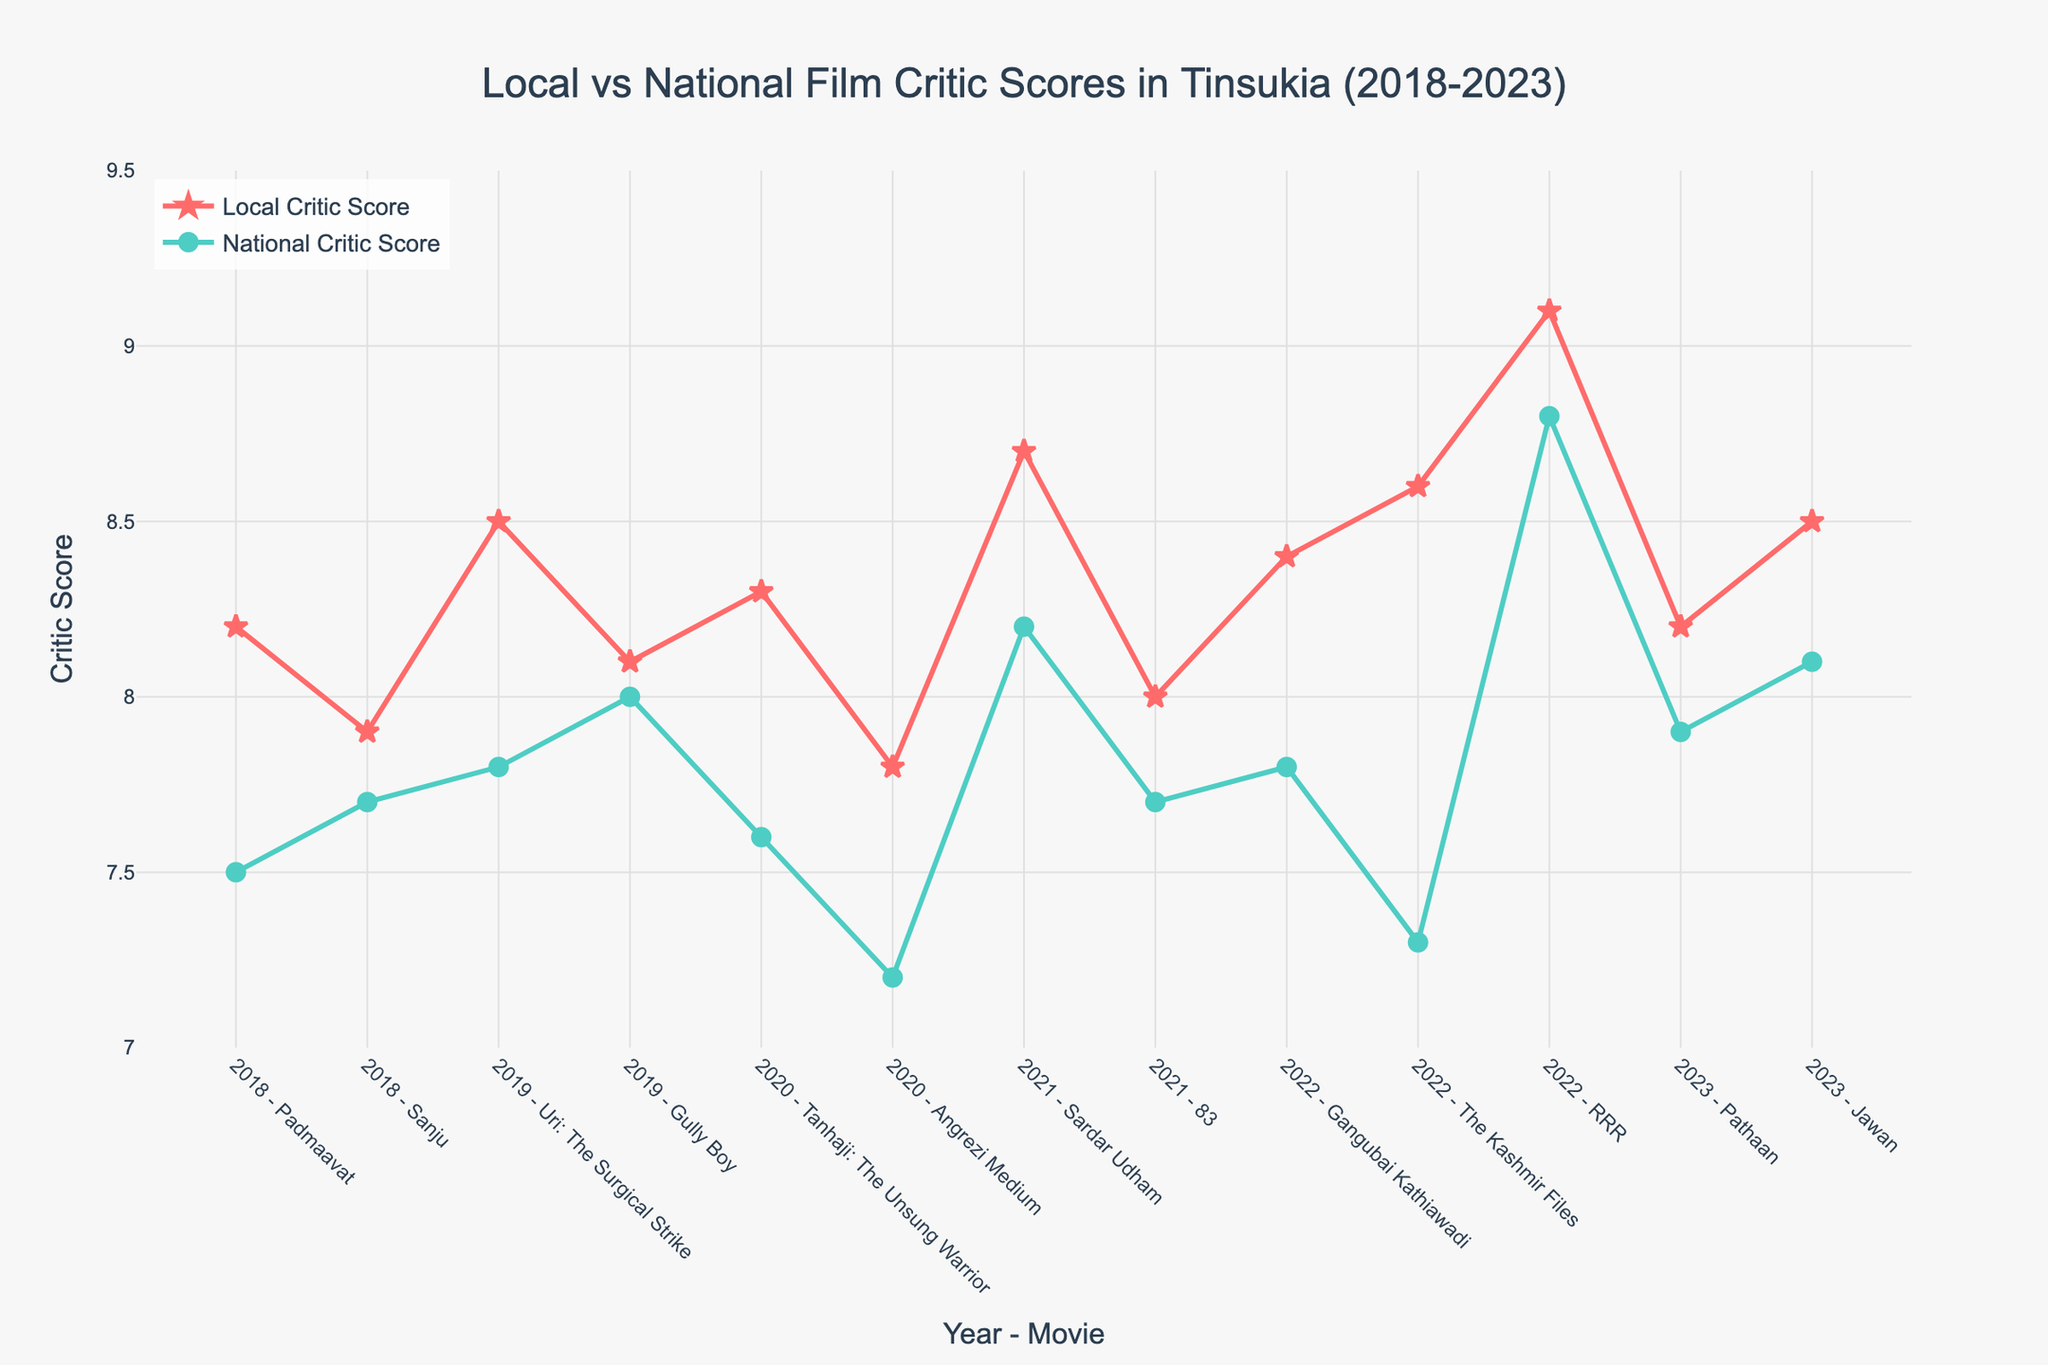What movie received the highest local critic score? The highest local critic score can be seen as the tallest point (marker) on the red line, which corresponds to RRR with a score of 9.1 in 2022.
Answer: RRR Which year had the smallest difference in scores between local and national critics? To find the smallest difference, observe the distance between the red and green markers for each year. The smallest difference appears in 2019 for 'Gully Boy' where the local score is 8.1 and the national score is 8.0, yielding a difference of 0.1.
Answer: 2019 (Gully Boy) What is the average local critic score for movies released in 2023? To compute the average score for 2023, add the local scores for 'Pathaan' (8.2) and 'Jawan' (8.5) and divide by 2. (8.2 + 8.5) / 2 = 8.35.
Answer: 8.35 Which movie shows a higher score by national critics compared to local critics? Look for instances where the green marker is above the corresponding red marker. For 'Padmaavat' in 2018, the national critic score (7.5) is below the local score (8.2), so actually none of the movies have higher national critic scores in this data.
Answer: None What is the highest difference between local and national critic scores? To find the highest difference, look for the greatest vertical gap between red and green markers. 'The Kashmir Files' in 2022 shows the largest difference: 8.6 (local) and 7.3 (national) resulting in a difference of 1.3.
Answer: 1.3 How many movies have a local critic score higher than 8.5? Count the markers on the red line which are above the 8.5 marking. The movies are 'Uri: The Surgical Strike,' 'Sardar Udham,' 'The Kashmir Files,' and 'RRR.' Hence, there are 4 movies.
Answer: 4 Which year shows the most consistent scores between local and national critics, and what is the range of their differences? Consistency can be determined by how closely the red and green markers follow each other. 2019 shows the most consistent scores ('Uri': 8.5 vs 7.8 and 'Gully Boy': 8.1 vs 8.0). The differences are 0.7 and 0.1 respectively. The range of difference is 0.7 - 0.1 = 0.6.
Answer: 2019, range 0.6 